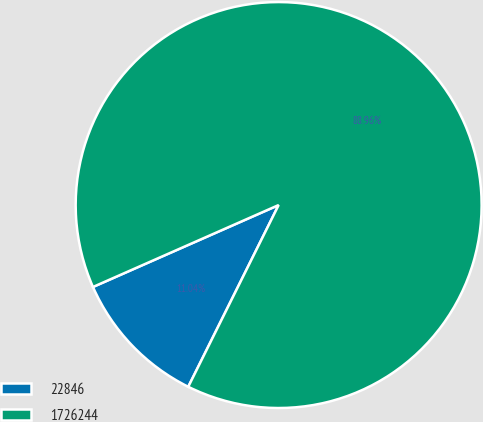Convert chart. <chart><loc_0><loc_0><loc_500><loc_500><pie_chart><fcel>22846<fcel>1726244<nl><fcel>11.04%<fcel>88.96%<nl></chart> 